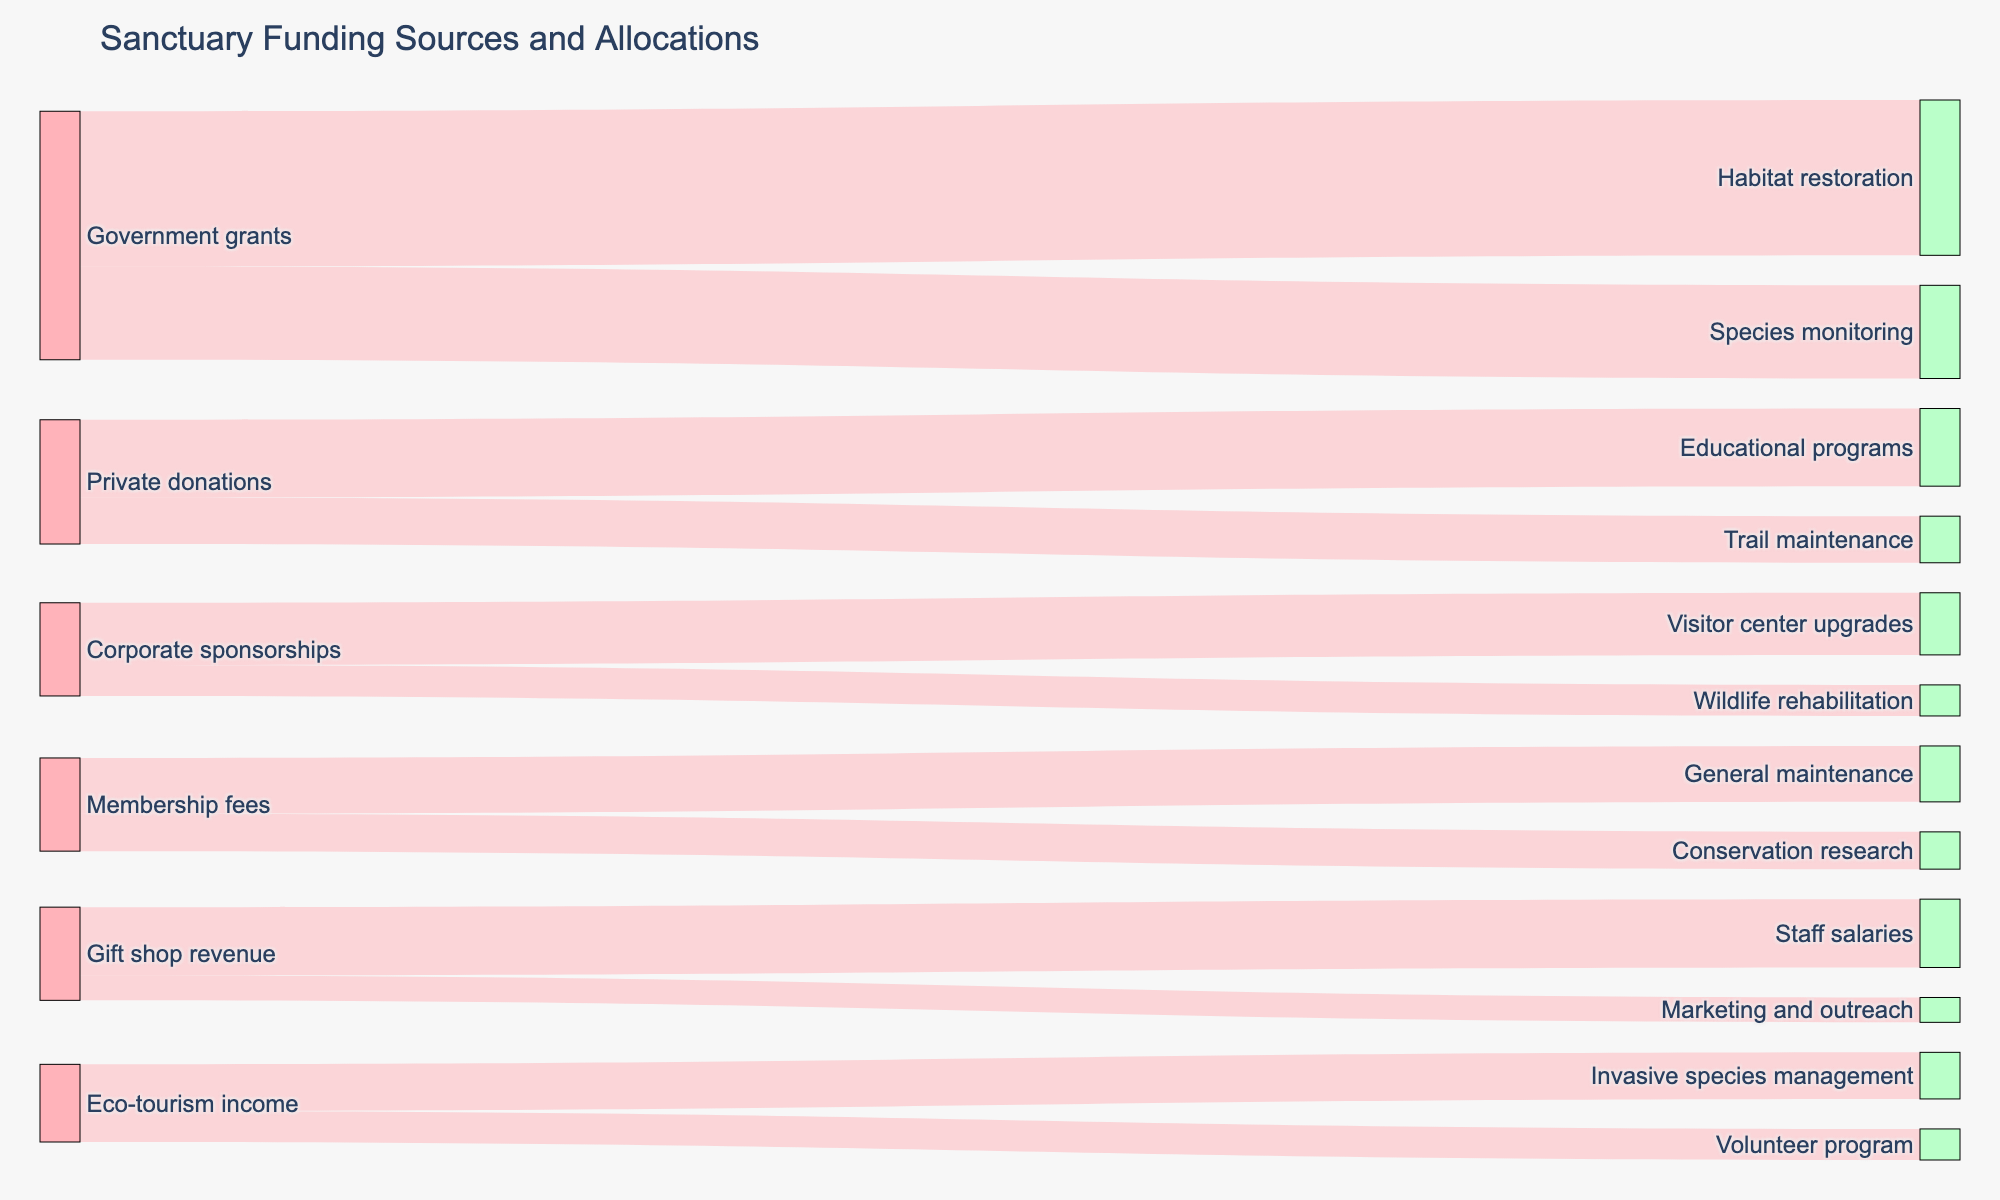Who provides the most funding according to the diagram? The government grants provide the most funding. By looking at the figure, we can see the thickness of the flow from government grants to its allocations is the most significant, indicating the highest funding.
Answer: Government grants Which funding source contributes to Habitat restoration? By observing the diagram, we can trace the flow leading to Habitat restoration. The source of this flow is Government grants.
Answer: Government grants How much funding is allocated to Educational programs? The flow from Private donations to Educational programs represents the monetary value allocated, which is 250,000.
Answer: 250,000 What is the total funding coming from Corporate sponsorships? To find the total funding from Corporate sponsorships, add the amounts leading from it: 200,000 for Visitor center upgrades and 100,000 for Wildlife rehabilitation. Summing these amounts gives 300,000.
Answer: 300,000 Which destination receives the least funding? By comparing the thickness of the flows to all destinations, the one with the thinnest flow is Marketing and outreach, which receives 80,000 in funding.
Answer: Marketing and outreach How does the amount of funding for Trail maintenance compare with that for Conservation research? The flow to Trail maintenance from Private donations is 150,000, and the flow to Conservation research from Membership fees is 120,000. Comparing the two, Trail maintenance receives more funding.
Answer: Trail maintenance What percentage of the Membership fees is allocated to General maintenance? Membership fees provide a total of 180,000 for General maintenance and 120,000 for Conservation research. The total funding from Membership fees is 180,000 + 120,000 = 300,000. The percentage for General maintenance is (180,000 / 300,000) * 100% = 60%.
Answer: 60% How much funding does Eco-tourism income generate in total? Summing the values from Eco-tourism income to Invasive species management (150,000) and Volunteer program (100,000), we get a total of 250,000.
Answer: 250,000 Which funding source contributes to Marketing and outreach? By following the flow leading to Marketing and outreach, we see that the source is Gift shop revenue.
Answer: Gift shop revenue Compare the total funding between Gift shop revenue and Private donations. Which is greater? Adding the contributions from Gift shop revenue (220,000 + 80,000) totals 300,000. The total for Private donations (250,000 + 150,000) is also 400,000. Therefore, Private donations provide more funding.
Answer: Private donations 